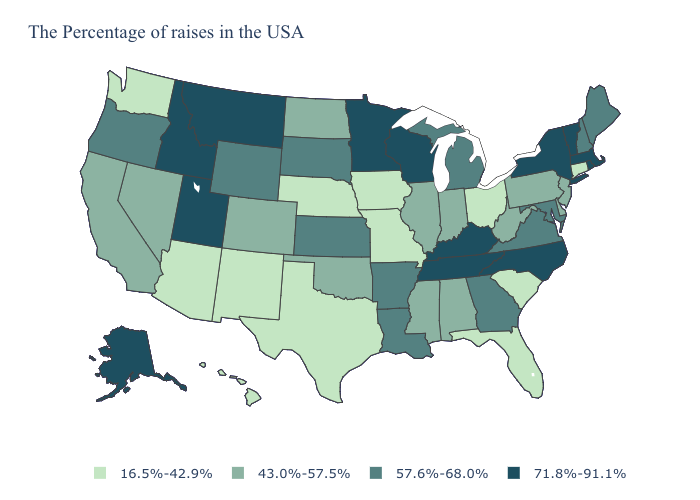What is the value of Missouri?
Short answer required. 16.5%-42.9%. Name the states that have a value in the range 57.6%-68.0%?
Give a very brief answer. Maine, New Hampshire, Maryland, Virginia, Georgia, Michigan, Louisiana, Arkansas, Kansas, South Dakota, Wyoming, Oregon. Name the states that have a value in the range 16.5%-42.9%?
Be succinct. Connecticut, South Carolina, Ohio, Florida, Missouri, Iowa, Nebraska, Texas, New Mexico, Arizona, Washington, Hawaii. What is the lowest value in the West?
Concise answer only. 16.5%-42.9%. Does the map have missing data?
Be succinct. No. Name the states that have a value in the range 43.0%-57.5%?
Write a very short answer. New Jersey, Delaware, Pennsylvania, West Virginia, Indiana, Alabama, Illinois, Mississippi, Oklahoma, North Dakota, Colorado, Nevada, California. What is the value of Tennessee?
Short answer required. 71.8%-91.1%. What is the value of Arizona?
Write a very short answer. 16.5%-42.9%. Name the states that have a value in the range 16.5%-42.9%?
Concise answer only. Connecticut, South Carolina, Ohio, Florida, Missouri, Iowa, Nebraska, Texas, New Mexico, Arizona, Washington, Hawaii. Which states have the lowest value in the USA?
Concise answer only. Connecticut, South Carolina, Ohio, Florida, Missouri, Iowa, Nebraska, Texas, New Mexico, Arizona, Washington, Hawaii. What is the lowest value in the Northeast?
Give a very brief answer. 16.5%-42.9%. Among the states that border Colorado , which have the lowest value?
Answer briefly. Nebraska, New Mexico, Arizona. What is the value of Idaho?
Short answer required. 71.8%-91.1%. Name the states that have a value in the range 16.5%-42.9%?
Quick response, please. Connecticut, South Carolina, Ohio, Florida, Missouri, Iowa, Nebraska, Texas, New Mexico, Arizona, Washington, Hawaii. 